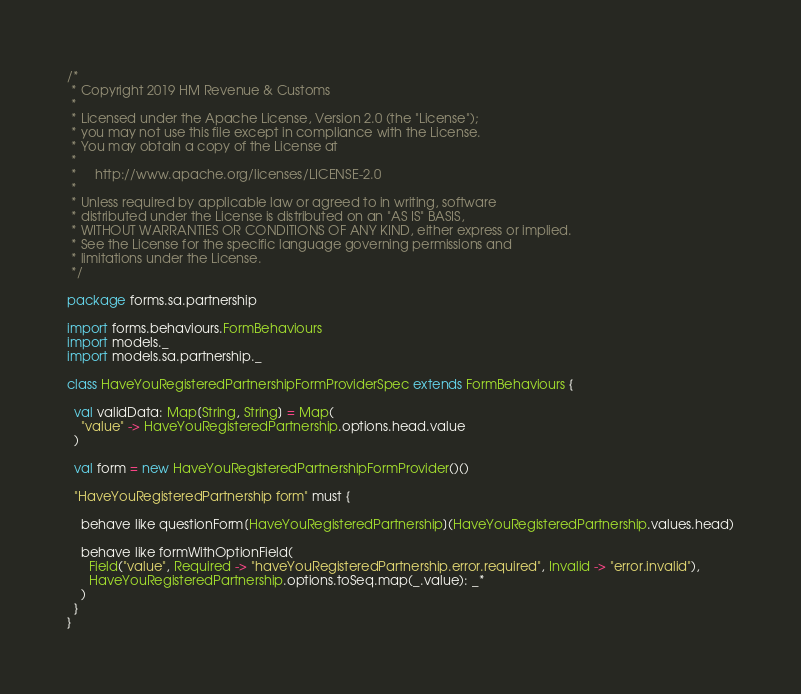<code> <loc_0><loc_0><loc_500><loc_500><_Scala_>/*
 * Copyright 2019 HM Revenue & Customs
 *
 * Licensed under the Apache License, Version 2.0 (the "License");
 * you may not use this file except in compliance with the License.
 * You may obtain a copy of the License at
 *
 *     http://www.apache.org/licenses/LICENSE-2.0
 *
 * Unless required by applicable law or agreed to in writing, software
 * distributed under the License is distributed on an "AS IS" BASIS,
 * WITHOUT WARRANTIES OR CONDITIONS OF ANY KIND, either express or implied.
 * See the License for the specific language governing permissions and
 * limitations under the License.
 */

package forms.sa.partnership

import forms.behaviours.FormBehaviours
import models._
import models.sa.partnership._

class HaveYouRegisteredPartnershipFormProviderSpec extends FormBehaviours {

  val validData: Map[String, String] = Map(
    "value" -> HaveYouRegisteredPartnership.options.head.value
  )

  val form = new HaveYouRegisteredPartnershipFormProvider()()

  "HaveYouRegisteredPartnership form" must {

    behave like questionForm[HaveYouRegisteredPartnership](HaveYouRegisteredPartnership.values.head)

    behave like formWithOptionField(
      Field("value", Required -> "haveYouRegisteredPartnership.error.required", Invalid -> "error.invalid"),
      HaveYouRegisteredPartnership.options.toSeq.map(_.value): _*
    )
  }
}
</code> 